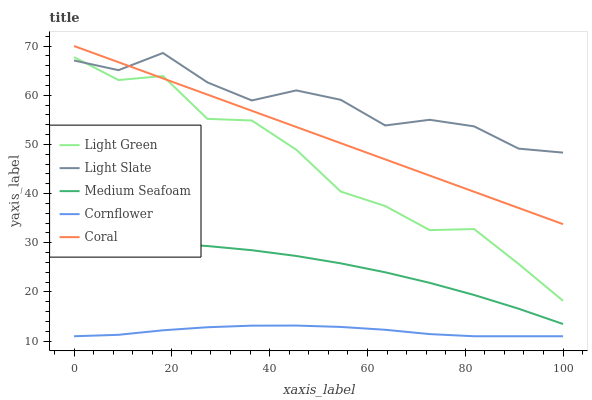Does Coral have the minimum area under the curve?
Answer yes or no. No. Does Coral have the maximum area under the curve?
Answer yes or no. No. Is Cornflower the smoothest?
Answer yes or no. No. Is Cornflower the roughest?
Answer yes or no. No. Does Coral have the lowest value?
Answer yes or no. No. Does Cornflower have the highest value?
Answer yes or no. No. Is Cornflower less than Coral?
Answer yes or no. Yes. Is Coral greater than Cornflower?
Answer yes or no. Yes. Does Cornflower intersect Coral?
Answer yes or no. No. 